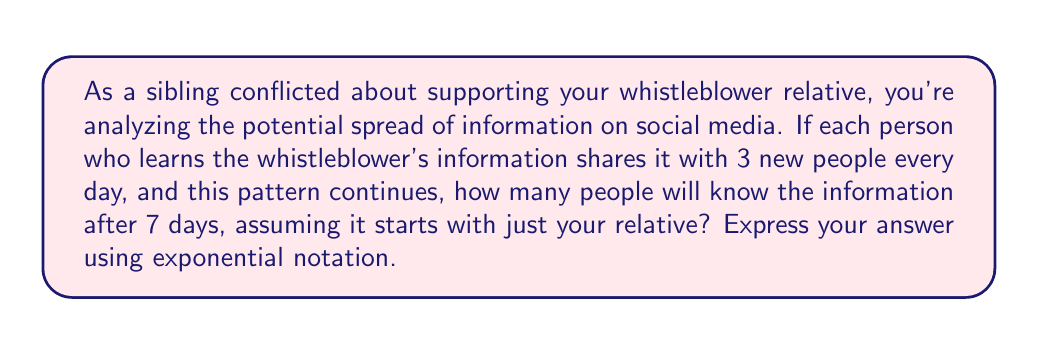Could you help me with this problem? Let's approach this step-by-step:

1) We start with 1 person (your relative) on day 0.

2) Each day, the number of people who know the information triples.

3) This can be represented by the exponential function:

   $f(x) = 1 \cdot 3^x$

   Where $x$ is the number of days and $f(x)$ is the number of people who know the information.

4) We want to know the number of people after 7 days, so we plug in $x = 7$:

   $f(7) = 1 \cdot 3^7$

5) To calculate this:

   $$\begin{align}
   3^7 &= 3 \cdot 3 \cdot 3 \cdot 3 \cdot 3 \cdot 3 \cdot 3 \\
   &= 2187
   \end{align}$$

Thus, after 7 days, 2187 people will know the information.

This demonstrates the exponential nature of information spread in social networks, highlighting the potential rapid dissemination of your relative's whistleblowing information.
Answer: $3^7 = 2187$ people 